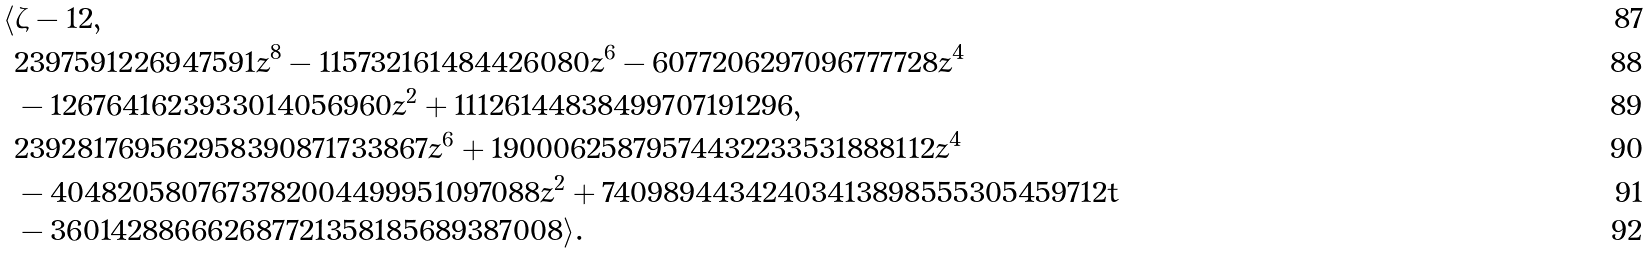<formula> <loc_0><loc_0><loc_500><loc_500>\langle & \zeta - 1 2 , \\ & 2 3 9 7 5 9 1 2 2 6 9 4 7 5 9 1 z ^ { 8 } - 1 1 5 7 3 2 1 6 1 4 8 4 4 2 6 0 8 0 z ^ { 6 } - 6 0 7 7 2 0 6 2 9 7 0 9 6 7 7 7 7 2 8 z ^ { 4 } \\ & - 1 2 6 7 6 4 1 6 2 3 9 3 3 0 1 4 0 5 6 9 6 0 z ^ { 2 } + 1 1 1 2 6 1 4 4 8 3 8 4 9 9 7 0 7 1 9 1 2 9 6 , \\ & 2 3 9 2 8 1 7 6 9 5 6 2 9 5 8 3 9 0 8 7 1 7 3 3 8 6 7 z ^ { 6 } + 1 9 0 0 0 6 2 5 8 7 9 5 7 4 4 3 2 2 3 3 5 3 1 8 8 8 1 1 2 z ^ { 4 } \\ & - 4 0 4 8 2 0 5 8 0 7 6 7 3 7 8 2 0 0 4 4 9 9 9 5 1 0 9 7 0 8 8 z ^ { 2 } + 7 4 0 9 8 9 4 4 3 4 2 4 0 3 4 1 3 8 9 8 5 5 5 3 0 5 4 5 9 7 1 2 t \\ & - 3 6 0 1 4 2 8 8 6 6 6 2 6 8 7 7 2 1 3 5 8 1 8 5 6 8 9 3 8 7 0 0 8 \rangle .</formula> 